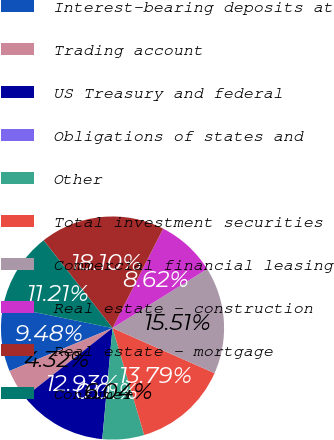Convert chart to OTSL. <chart><loc_0><loc_0><loc_500><loc_500><pie_chart><fcel>Interest-bearing deposits at<fcel>Trading account<fcel>US Treasury and federal<fcel>Obligations of states and<fcel>Other<fcel>Total investment securities<fcel>Commercial financial leasing<fcel>Real estate - construction<fcel>Real estate - mortgage<fcel>Consumer<nl><fcel>9.48%<fcel>4.32%<fcel>12.93%<fcel>0.01%<fcel>6.04%<fcel>13.79%<fcel>15.51%<fcel>8.62%<fcel>18.1%<fcel>11.21%<nl></chart> 